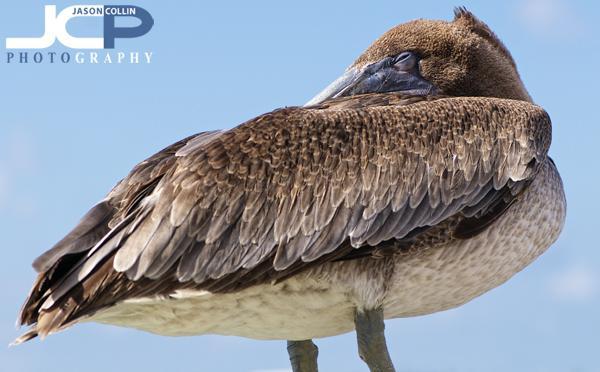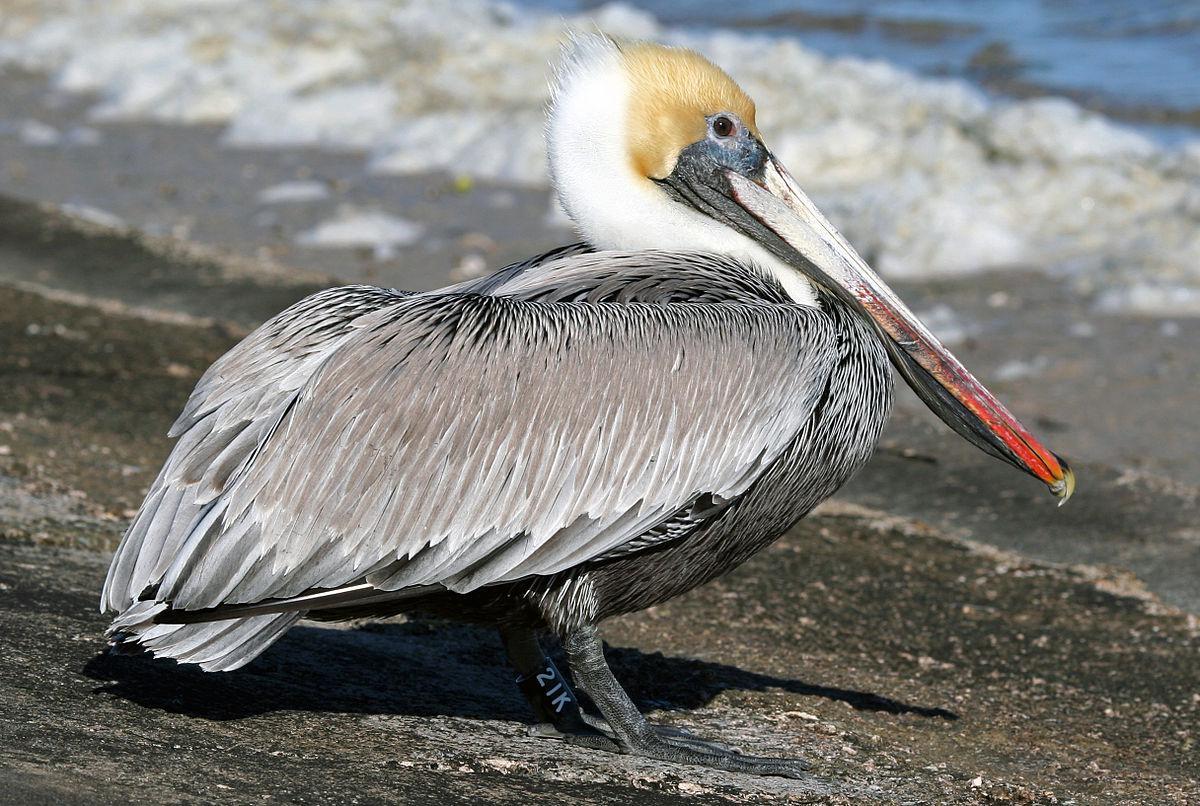The first image is the image on the left, the second image is the image on the right. Considering the images on both sides, is "Each image shows a single pelican standing on its legs." valid? Answer yes or no. Yes. The first image is the image on the left, the second image is the image on the right. Examine the images to the left and right. Is the description "There are only two birds that are standing." accurate? Answer yes or no. Yes. 